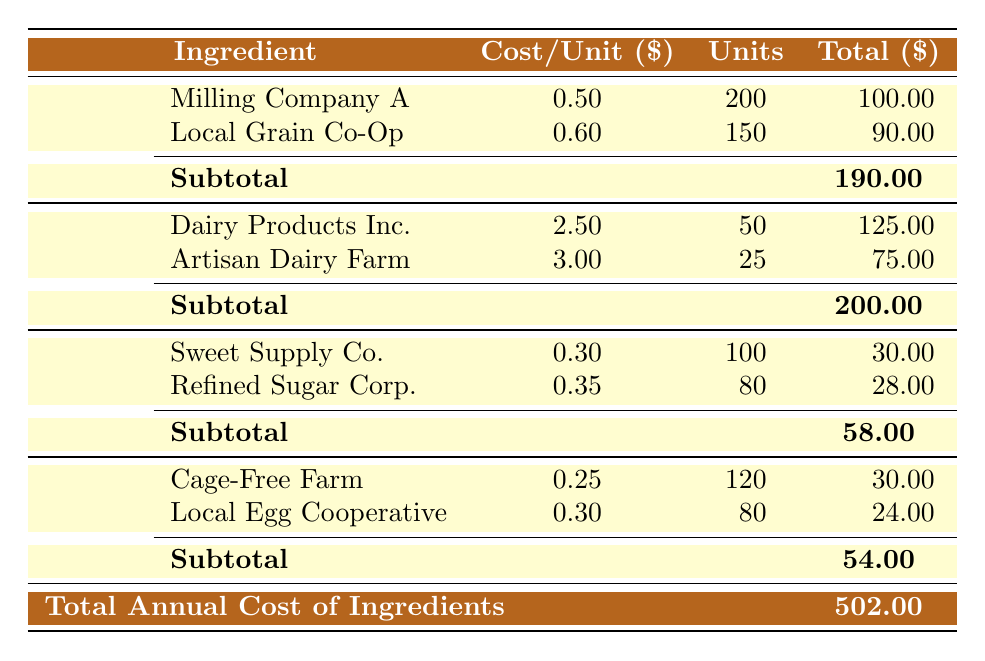What is the total amount spent on flour? The table shows the subtotal for flour, which is explicitly listed as 190. Therefore, the total amount spent on flour is 190.
Answer: 190 Who is the supplier for eggs with the highest cost per unit? By comparing the cost per unit for both suppliers of eggs, Cage-Free Farm has a cost of 0.25 per unit, and Local Egg Cooperative has a cost of 0.30 per unit. Thus, Local Egg Cooperative is the supplier with the highest cost per unit.
Answer: Local Egg Cooperative What is the total cost of all ingredients combined? At the bottom of the table, the total annual cost of ingredients is summarized as 502. Therefore, the total cost of all ingredients combined is 502.
Answer: 502 Which ingredient has the lowest total spent? To determine this, we compare the total spent for each ingredient: Flour (190), Butter (200), Sugar (58), and Eggs (54). The lowest total spent is on eggs, which amounts to 54.
Answer: Eggs Is the cost per unit for any supplier of butter greater than 3 dollars? Looking at the suppliers for butter, Dairy Products Inc. has a cost per unit of 2.50, and Artisan Dairy Farm has a cost of 3.00. Since none exceed 3 dollars, the answer is no.
Answer: No What is the average cost per unit for the suppliers of sugar? The costs per unit for sugar are 0.30 and 0.35. To find the average, we add 0.30 and 0.35, getting 0.65, and then divide by 2 (the number of suppliers) which results in 0.325.
Answer: 0.325 Which ingredient has the highest total cost? We evaluate the total costs for each ingredient: Flour (190), Butter (200), Sugar (58), and Eggs (54). Butter has the highest total cost at 200.
Answer: Butter What are the total units purchased for eggs? The table provides units purchased for Cage-Free Farm (120) and Local Egg Cooperative (80). Adding these together gives us a total of 200 units purchased for eggs.
Answer: 200 Have we spent more on butter than sugar? The total spent on butter is 200, and on sugar, it is 58. Since 200 is greater than 58, the answer to this question is yes.
Answer: Yes 